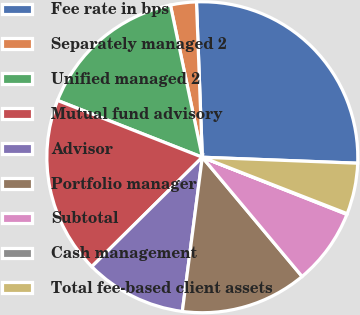Convert chart. <chart><loc_0><loc_0><loc_500><loc_500><pie_chart><fcel>Fee rate in bps<fcel>Separately managed 2<fcel>Unified managed 2<fcel>Mutual fund advisory<fcel>Advisor<fcel>Portfolio manager<fcel>Subtotal<fcel>Cash management<fcel>Total fee-based client assets<nl><fcel>26.21%<fcel>2.69%<fcel>15.76%<fcel>18.37%<fcel>10.53%<fcel>13.14%<fcel>7.92%<fcel>0.08%<fcel>5.3%<nl></chart> 